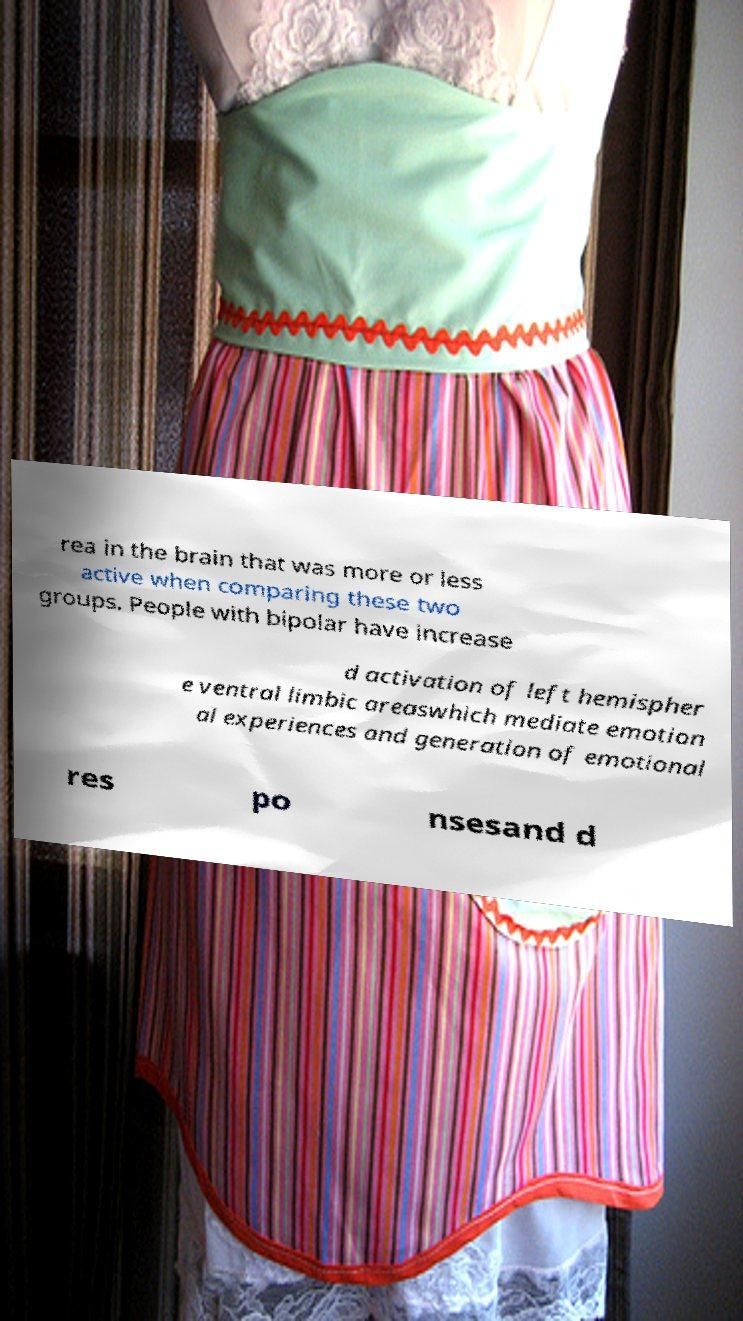Can you accurately transcribe the text from the provided image for me? rea in the brain that was more or less active when comparing these two groups. People with bipolar have increase d activation of left hemispher e ventral limbic areaswhich mediate emotion al experiences and generation of emotional res po nsesand d 